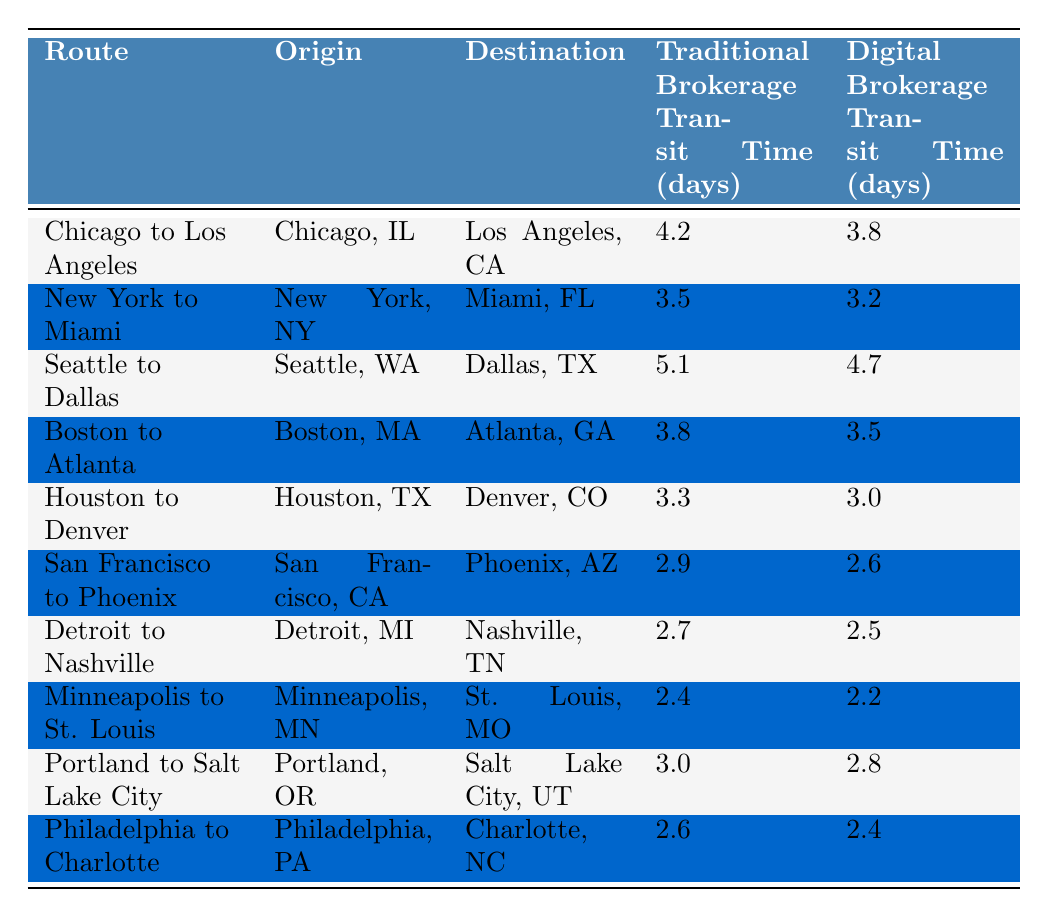What is the fastest route using traditional brokerage? By looking at the column labeled "Traditional Brokerage Transit Time (days)", the shortest time listed is 2.4 days, which corresponds to the route "Minneapolis to St. Louis".
Answer: Minneapolis to St. Louis What is the average transit time for digital brokerage across all routes? To calculate the average, sum the digital transit times: (3.8 + 3.2 + 4.7 + 3.5 + 3.0 + 2.6 + 2.5 + 2.2 + 2.8 + 2.4) = 28.7. Then, divide by the number of routes, which is 10. The average is 28.7 / 10 = 2.87 days.
Answer: 2.87 Is the transit time shorter for digital brokerage on all routes? By reviewing each route in the table, it's evident that for each entry, the digital brokerage time is less than the traditional brokerage time, confirming that digital brokerage is always faster.
Answer: Yes What is the difference in transit time between Houston to Denver for both brokerage methods? Looking at the respective times, traditional brokerage takes 3.3 days while digital brokerage takes 3.0 days. The difference is 3.3 - 3.0 = 0.3 days.
Answer: 0.3 days Which route experiences the greatest difference in transit times between traditional and digital brokerage? To find the greatest difference, calculate the difference for each route: Chicago to Los Angeles (0.4), New York to Miami (0.3), Seattle to Dallas (0.4), etc. The highest difference occurs with Seattle to Dallas, where both methods have a difference of 0.4 days.
Answer: Seattle to Dallas What is the total transit time for both brokerage methods for the route from San Francisco to Phoenix? For this route, traditional brokerage takes 2.9 days and digital brokerage takes 2.6 days. Adding these gives 2.9 + 2.6 = 5.5 days total transit time.
Answer: 5.5 days Which origin has the highest transit time when using traditional brokerage? By examining the traditional transit times listed, the highest time is 5.1 days for the route from Seattle to Dallas.
Answer: Seattle to Dallas How much faster is the digital brokerage method on average compared to the traditional brokerage method? First, calculate the average for both methods: Traditional average is (4.2 + 3.5 + 5.1 + 3.8 + 3.3 + 2.9 + 2.7 + 2.4 + 3.0 + 2.6) = 34.5, and then divide by 10, which gives 3.45 days. Digital average is 2.87 days as calculated earlier. The difference is 3.45 - 2.87 = 0.58 days faster for digital.
Answer: 0.58 days Which route has the smallest transit time difference between brokerage methods? By comparing the differences for each route, the smallest difference is found on the route from Detroit to Nashville with a difference of 0.2 days (2.7 - 2.5).
Answer: Detroit to Nashville Is the transit time from Boston to Atlanta more than 3.5 days for traditional brokerage? Checking the table, the transit time for Boston to Atlanta under traditional brokerage is 3.8 days, which is greater than 3.5 days.
Answer: Yes 